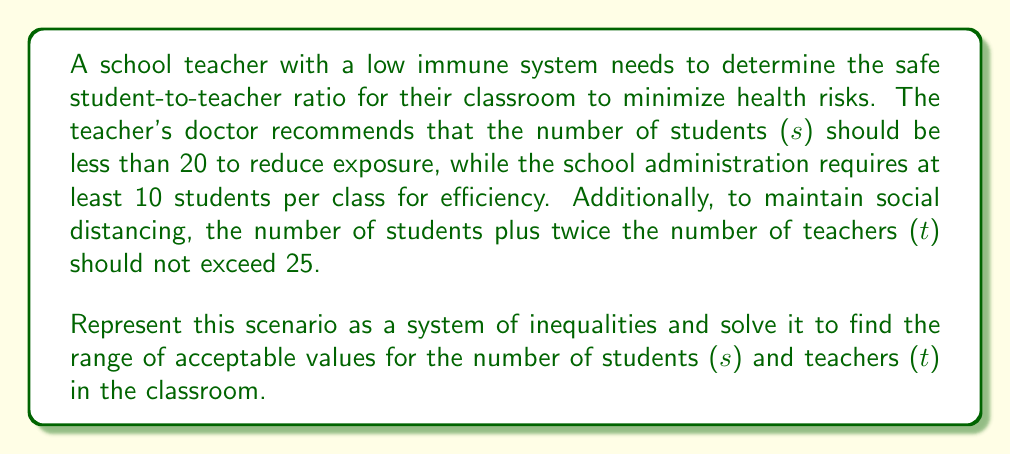Give your solution to this math problem. Let's approach this step-by-step:

1) First, let's translate the given information into inequalities:

   - Number of students should be less than 20: $s < 20$
   - Number of students should be at least 10: $s \geq 10$
   - Number of students plus twice the number of teachers should not exceed 25: $s + 2t \leq 25$

2) Our system of inequalities is:

   $$
   \begin{cases}
   10 \leq s < 20 \\
   s + 2t \leq 25
   \end{cases}
   $$

3) To solve this system, we need to consider the constraints on s and t:

   - From the first inequality, we know that s is between 10 and 20 (including 10 but not 20).
   - We can rearrange the second inequality to express t in terms of s:
     $2t \leq 25 - s$
     $t \leq \frac{25-s}{2}$

4) Now, let's consider the extreme cases:

   - When s = 10 (minimum number of students):
     $t \leq \frac{25-10}{2} = 7.5$
     Since t must be a whole number, the maximum number of teachers when s = 10 is 7.

   - When s = 19 (maximum number of students, since s < 20):
     $t \leq \frac{25-19}{2} = 3$
     The maximum number of teachers when s = 19 is 3.

5) Therefore, the range of acceptable values is:

   - For students (s): 10 ≤ s ≤ 19
   - For teachers (t): 1 ≤ t ≤ 7 (assuming at least one teacher is required)

The student-to-teacher ratio can be expressed as s:t, where s and t are within these ranges.
Answer: The safe student-to-teacher ratio can be any combination where:
$10 \leq s \leq 19$ and $1 \leq t \leq 7$, subject to the constraint $s + 2t \leq 25$.

Possible ratios range from 10:7 (lowest number of students to highest number of teachers) to 19:1 (highest number of students to lowest number of teachers). 